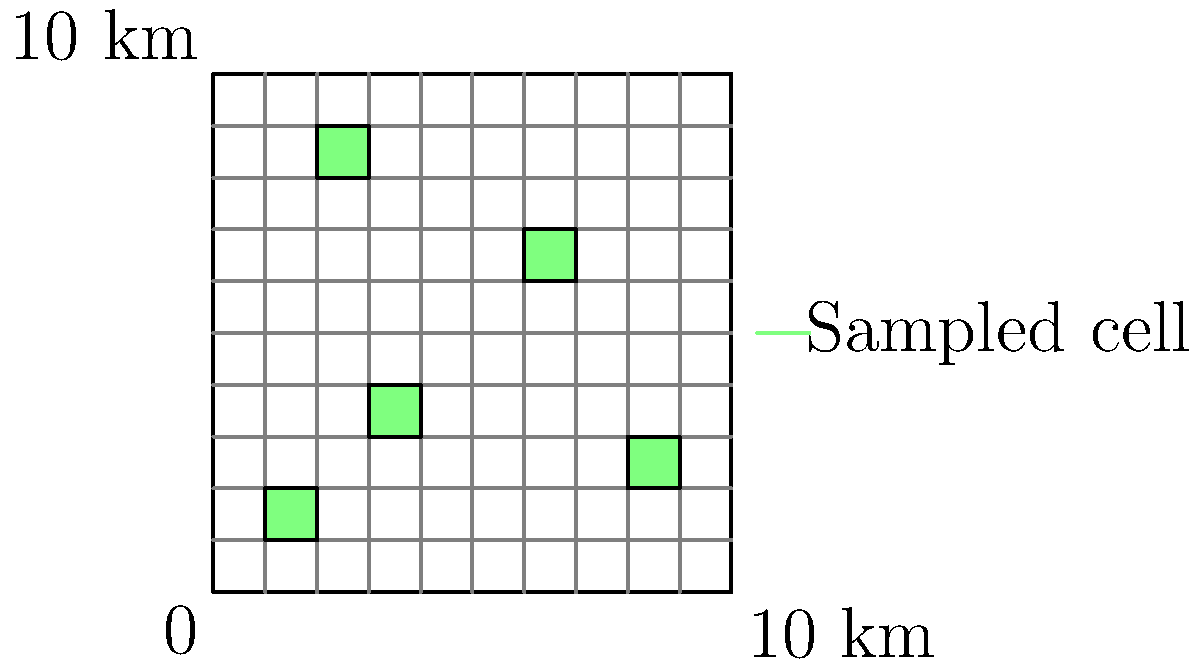In a 10 km x 10 km habitat area, you've conducted a grid-based sampling survey for an endangered species. The area is divided into 100 cells of 1 km² each. Five randomly selected cells were surveyed, and a total of 15 individuals were counted. Estimate the total population of the endangered species in the entire habitat area. What is the estimated population density per km²? To estimate the total population and population density, we'll follow these steps:

1. Calculate the sample area:
   - Each cell is 1 km², and 5 cells were surveyed
   - Sample area = $5 \text{ km}^2$

2. Calculate the total habitat area:
   - Total area = $10 \text{ km} \times 10 \text{ km} = 100 \text{ km}^2$

3. Calculate the proportion of the area sampled:
   - Proportion = $\frac{\text{Sample area}}{\text{Total area}} = \frac{5 \text{ km}^2}{100 \text{ km}^2} = 0.05$ or 5%

4. Estimate the total population:
   - 15 individuals were counted in 5% of the area
   - Estimated total population = $\frac{15 \text{ individuals}}{0.05} = 300 \text{ individuals}$

5. Calculate the population density:
   - Density = $\frac{\text{Estimated total population}}{\text{Total area}}$
   - Density = $\frac{300 \text{ individuals}}{100 \text{ km}^2} = 3 \text{ individuals/km}^2$

Therefore, the estimated total population is 300 individuals, and the estimated population density is 3 individuals/km².
Answer: 300 individuals; 3 individuals/km² 